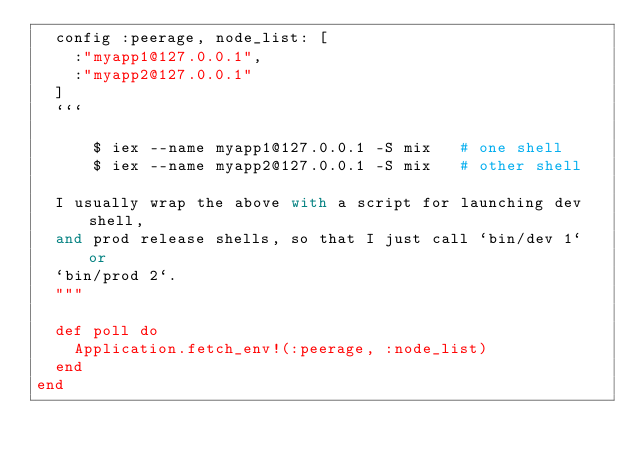Convert code to text. <code><loc_0><loc_0><loc_500><loc_500><_Elixir_>  config :peerage, node_list: [
    :"myapp1@127.0.0.1",
    :"myapp2@127.0.0.1"
  ]
  ```

      $ iex --name myapp1@127.0.0.1 -S mix   # one shell
      $ iex --name myapp2@127.0.0.1 -S mix   # other shell

  I usually wrap the above with a script for launching dev shell,
  and prod release shells, so that I just call `bin/dev 1` or
  `bin/prod 2`.
  """

  def poll do
    Application.fetch_env!(:peerage, :node_list)
  end
end
</code> 